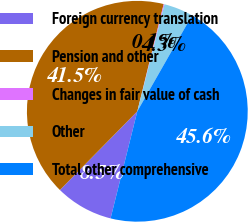Convert chart. <chart><loc_0><loc_0><loc_500><loc_500><pie_chart><fcel>Foreign currency translation<fcel>Pension and other<fcel>Changes in fair value of cash<fcel>Other<fcel>Total other comprehensive<nl><fcel>8.47%<fcel>41.47%<fcel>0.12%<fcel>4.29%<fcel>45.64%<nl></chart> 